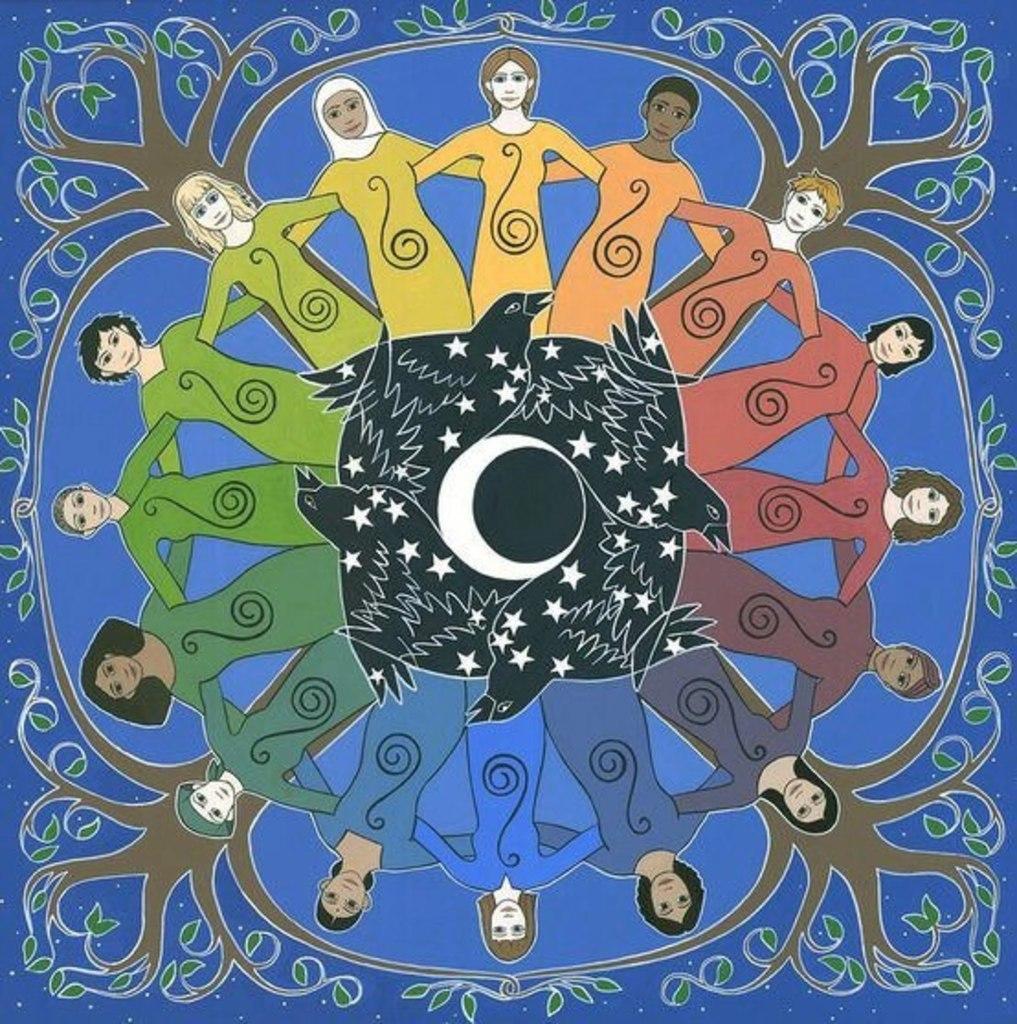Describe this image in one or two sentences. Here we can see an animated picture, in this picture we can see trees, persons and birds. 